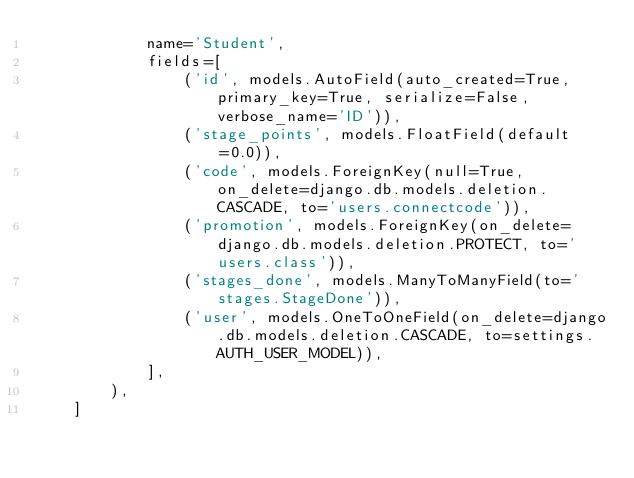<code> <loc_0><loc_0><loc_500><loc_500><_Python_>            name='Student',
            fields=[
                ('id', models.AutoField(auto_created=True, primary_key=True, serialize=False, verbose_name='ID')),
                ('stage_points', models.FloatField(default=0.0)),
                ('code', models.ForeignKey(null=True, on_delete=django.db.models.deletion.CASCADE, to='users.connectcode')),
                ('promotion', models.ForeignKey(on_delete=django.db.models.deletion.PROTECT, to='users.class')),
                ('stages_done', models.ManyToManyField(to='stages.StageDone')),
                ('user', models.OneToOneField(on_delete=django.db.models.deletion.CASCADE, to=settings.AUTH_USER_MODEL)),
            ],
        ),
    ]
</code> 